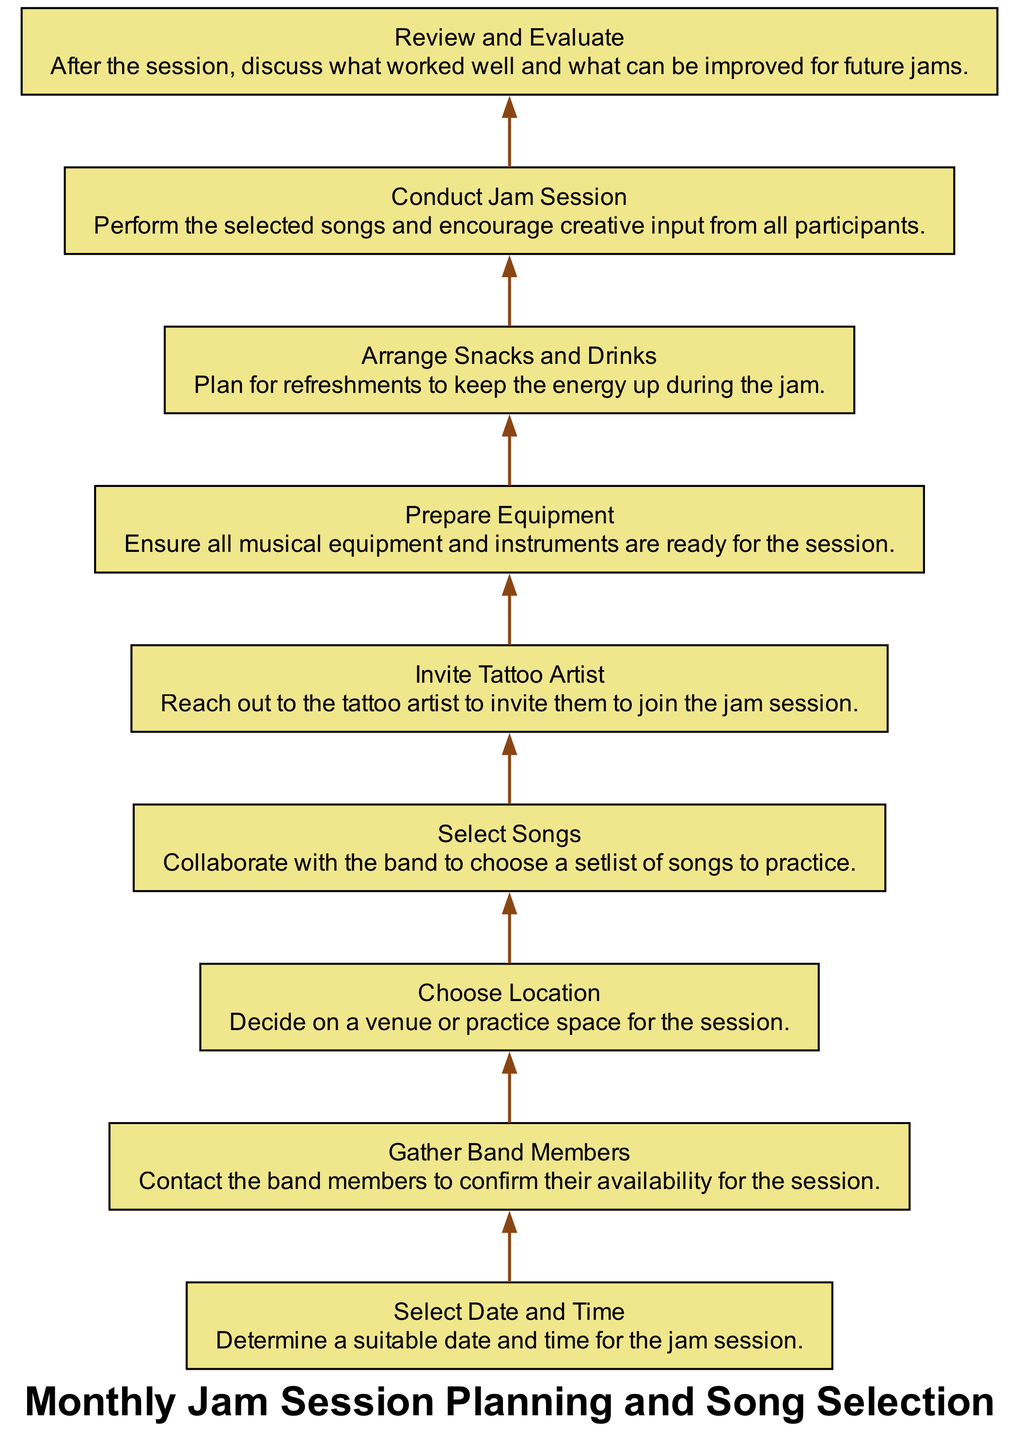What is the first step in the jam session planning process? The first step is "Select Date and Time," as indicated at the top of the flow chart. This node represents the initial action to determine a suitable time for the session.
Answer: Select Date and Time How many elements are there in the flowchart? The flowchart includes a total of nine elements (or nodes) representing different steps in the planning process.
Answer: Nine What comes after "Gather Band Members"? Following "Gather Band Members," the next step is "Choose Location," which indicates the need to select a venue for the session.
Answer: Choose Location What is the last step in the process? The last step in the flowchart is "Review and Evaluate," which involves discussing the session's effectiveness and areas for improvement.
Answer: Review and Evaluate How many edges connect the nodes in this diagram? There are eight edges that connect the nine nodes in the flowchart, indicating the sequential flow from one step to the next.
Answer: Eight Which step directly precedes the "Conduct Jam Session"? The step that directly precedes "Conduct Jam Session" is "Arrange Snacks and Drinks," which suggests preparing refreshments before the performance.
Answer: Arrange Snacks and Drinks What type of feedback is gathered in the last step? The final step gathers "Review and Evaluate," focusing on feedback about what worked well and what could be improved for future jamming sessions.
Answer: Feedback Which node involves collaboration with the band? The node titled "Select Songs" involves collaboration with the band members to choose a setlist of songs to practice during the session.
Answer: Select Songs What is the relationship established between "Invite Tattoo Artist" and "Prepare Equipment"? The relationship shows that "Invite Tattoo Artist" must happen before "Prepare Equipment," implying that the artist's attendance is confirmed prior to preparing the necessary gear.
Answer: Sequential relationship 